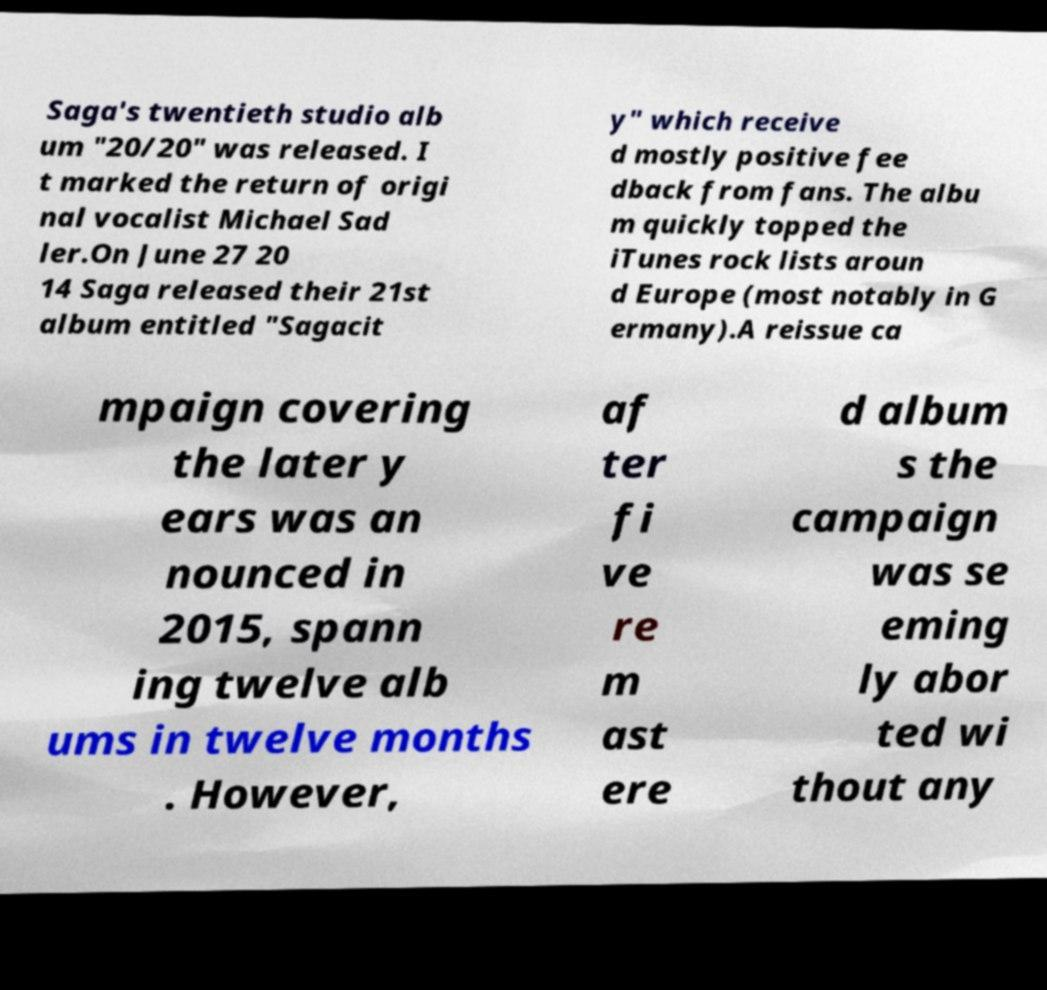I need the written content from this picture converted into text. Can you do that? Saga's twentieth studio alb um "20/20" was released. I t marked the return of origi nal vocalist Michael Sad ler.On June 27 20 14 Saga released their 21st album entitled "Sagacit y" which receive d mostly positive fee dback from fans. The albu m quickly topped the iTunes rock lists aroun d Europe (most notably in G ermany).A reissue ca mpaign covering the later y ears was an nounced in 2015, spann ing twelve alb ums in twelve months . However, af ter fi ve re m ast ere d album s the campaign was se eming ly abor ted wi thout any 